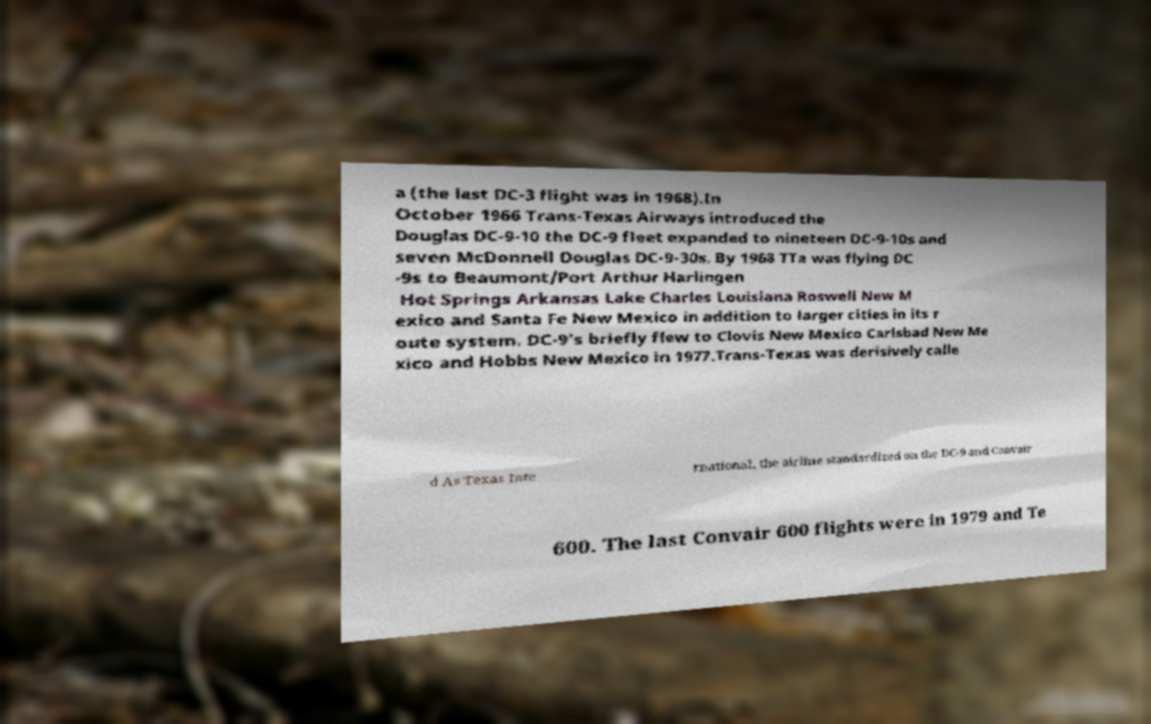Could you assist in decoding the text presented in this image and type it out clearly? a (the last DC-3 flight was in 1968).In October 1966 Trans-Texas Airways introduced the Douglas DC-9-10 the DC-9 fleet expanded to nineteen DC-9-10s and seven McDonnell Douglas DC-9-30s. By 1968 TTa was flying DC -9s to Beaumont/Port Arthur Harlingen Hot Springs Arkansas Lake Charles Louisiana Roswell New M exico and Santa Fe New Mexico in addition to larger cities in its r oute system. DC-9's briefly flew to Clovis New Mexico Carlsbad New Me xico and Hobbs New Mexico in 1977.Trans-Texas was derisively calle d As Texas Inte rnational, the airline standardized on the DC-9 and Convair 600. The last Convair 600 flights were in 1979 and Te 